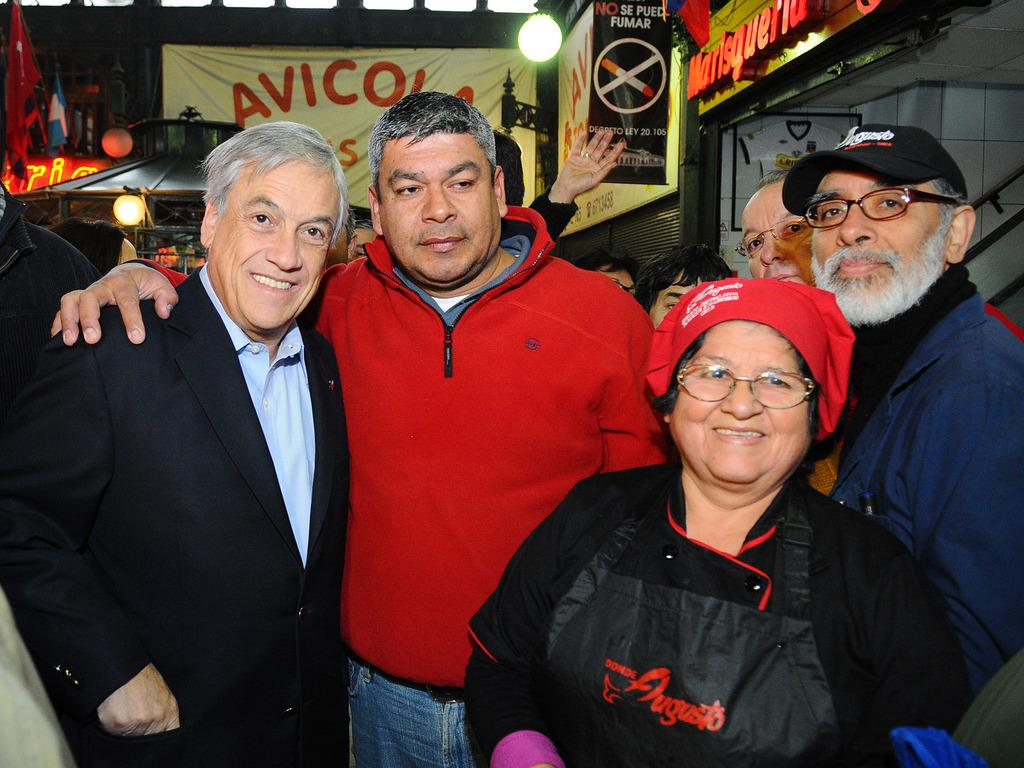What are the people in the image doing? The people in the image are standing in the center. What can be seen in the background of the image? There are banners and a wall visible in the background. Is there any source of light in the image? Yes, there is a light visible in the image. Where is the faucet located in the image? There is no faucet present in the image. What type of honey is being served to the people in the image? There is no honey present in the image. 